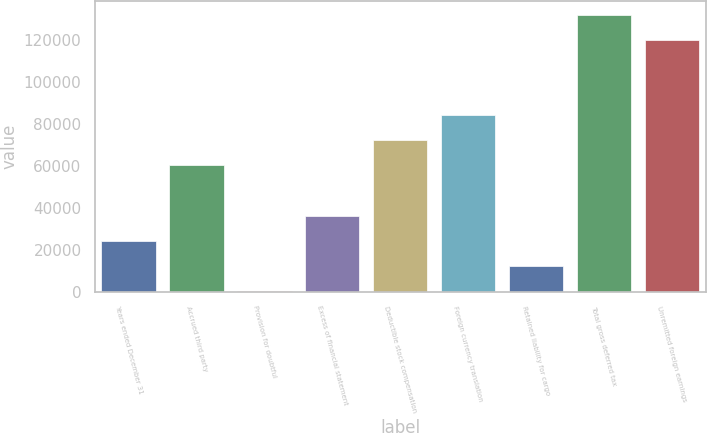<chart> <loc_0><loc_0><loc_500><loc_500><bar_chart><fcel>Years ended December 31<fcel>Accrued third party<fcel>Provision for doubtful<fcel>Excess of financial statement<fcel>Deductible stock compensation<fcel>Foreign currency translation<fcel>Retained liability for cargo<fcel>Total gross deferred tax<fcel>Unremitted foreign earnings<nl><fcel>24431.6<fcel>60333.5<fcel>497<fcel>36398.9<fcel>72300.8<fcel>84268.1<fcel>12464.3<fcel>132137<fcel>120170<nl></chart> 